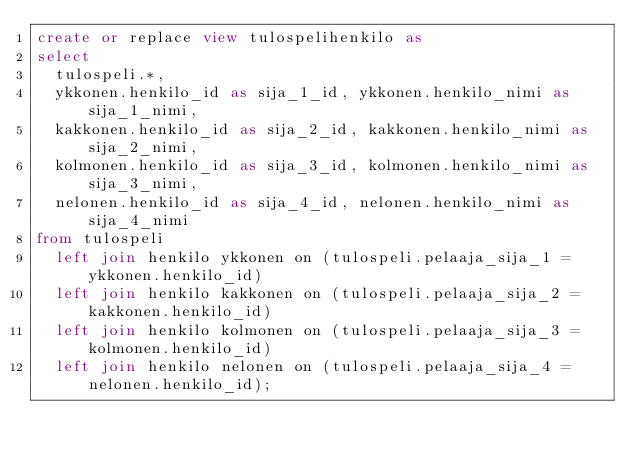<code> <loc_0><loc_0><loc_500><loc_500><_SQL_>create or replace view tulospelihenkilo as
select
  tulospeli.*,
  ykkonen.henkilo_id as sija_1_id, ykkonen.henkilo_nimi as sija_1_nimi,
  kakkonen.henkilo_id as sija_2_id, kakkonen.henkilo_nimi as sija_2_nimi,
  kolmonen.henkilo_id as sija_3_id, kolmonen.henkilo_nimi as sija_3_nimi,
  nelonen.henkilo_id as sija_4_id, nelonen.henkilo_nimi as sija_4_nimi
from tulospeli
  left join henkilo ykkonen on (tulospeli.pelaaja_sija_1 = ykkonen.henkilo_id)
  left join henkilo kakkonen on (tulospeli.pelaaja_sija_2 = kakkonen.henkilo_id)
  left join henkilo kolmonen on (tulospeli.pelaaja_sija_3 = kolmonen.henkilo_id)
  left join henkilo nelonen on (tulospeli.pelaaja_sija_4 = nelonen.henkilo_id);</code> 